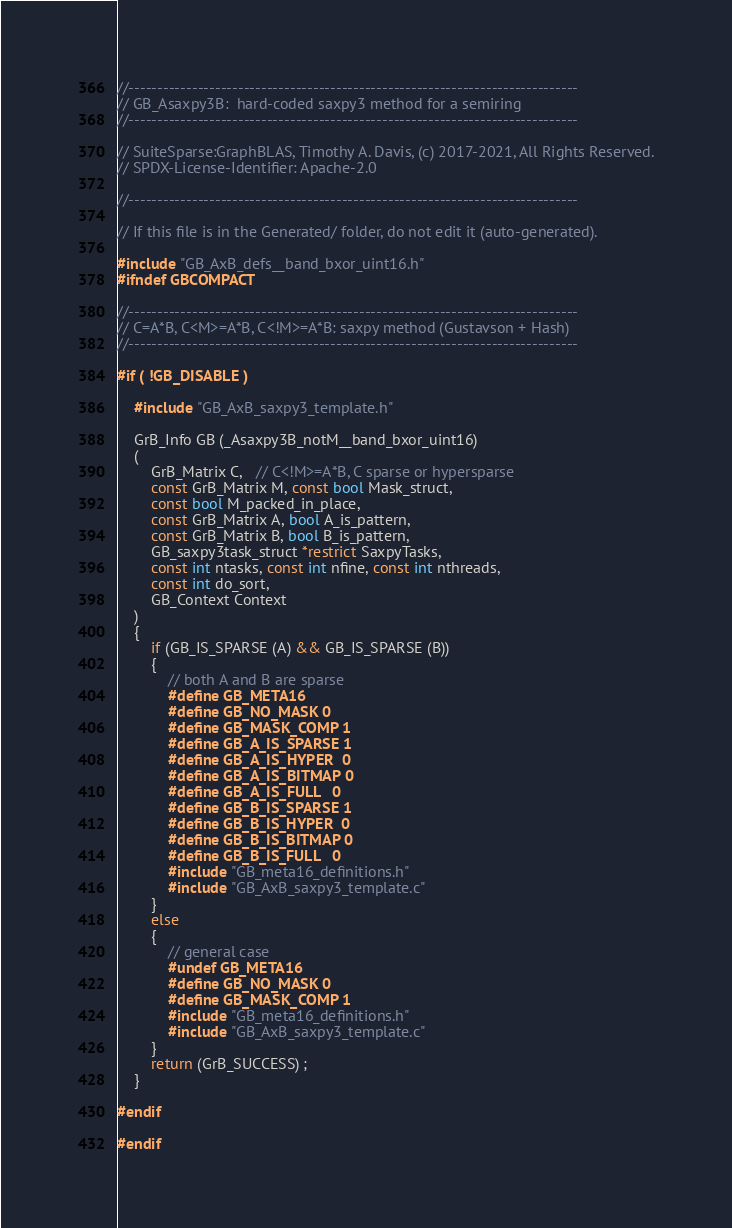<code> <loc_0><loc_0><loc_500><loc_500><_C_>//------------------------------------------------------------------------------
// GB_Asaxpy3B:  hard-coded saxpy3 method for a semiring
//------------------------------------------------------------------------------

// SuiteSparse:GraphBLAS, Timothy A. Davis, (c) 2017-2021, All Rights Reserved.
// SPDX-License-Identifier: Apache-2.0

//------------------------------------------------------------------------------

// If this file is in the Generated/ folder, do not edit it (auto-generated).

#include "GB_AxB_defs__band_bxor_uint16.h"
#ifndef GBCOMPACT

//------------------------------------------------------------------------------
// C=A*B, C<M>=A*B, C<!M>=A*B: saxpy method (Gustavson + Hash)
//------------------------------------------------------------------------------

#if ( !GB_DISABLE )

    #include "GB_AxB_saxpy3_template.h"

    GrB_Info GB (_Asaxpy3B_notM__band_bxor_uint16)
    (
        GrB_Matrix C,   // C<!M>=A*B, C sparse or hypersparse
        const GrB_Matrix M, const bool Mask_struct,
        const bool M_packed_in_place,
        const GrB_Matrix A, bool A_is_pattern,
        const GrB_Matrix B, bool B_is_pattern,
        GB_saxpy3task_struct *restrict SaxpyTasks,
        const int ntasks, const int nfine, const int nthreads,
        const int do_sort,
        GB_Context Context
    )
    {
        if (GB_IS_SPARSE (A) && GB_IS_SPARSE (B))
        {
            // both A and B are sparse
            #define GB_META16
            #define GB_NO_MASK 0
            #define GB_MASK_COMP 1
            #define GB_A_IS_SPARSE 1
            #define GB_A_IS_HYPER  0
            #define GB_A_IS_BITMAP 0
            #define GB_A_IS_FULL   0
            #define GB_B_IS_SPARSE 1
            #define GB_B_IS_HYPER  0
            #define GB_B_IS_BITMAP 0
            #define GB_B_IS_FULL   0
            #include "GB_meta16_definitions.h"
            #include "GB_AxB_saxpy3_template.c"
        }
        else
        {
            // general case
            #undef GB_META16
            #define GB_NO_MASK 0
            #define GB_MASK_COMP 1
            #include "GB_meta16_definitions.h"
            #include "GB_AxB_saxpy3_template.c"
        }
        return (GrB_SUCCESS) ;
    }

#endif

#endif

</code> 